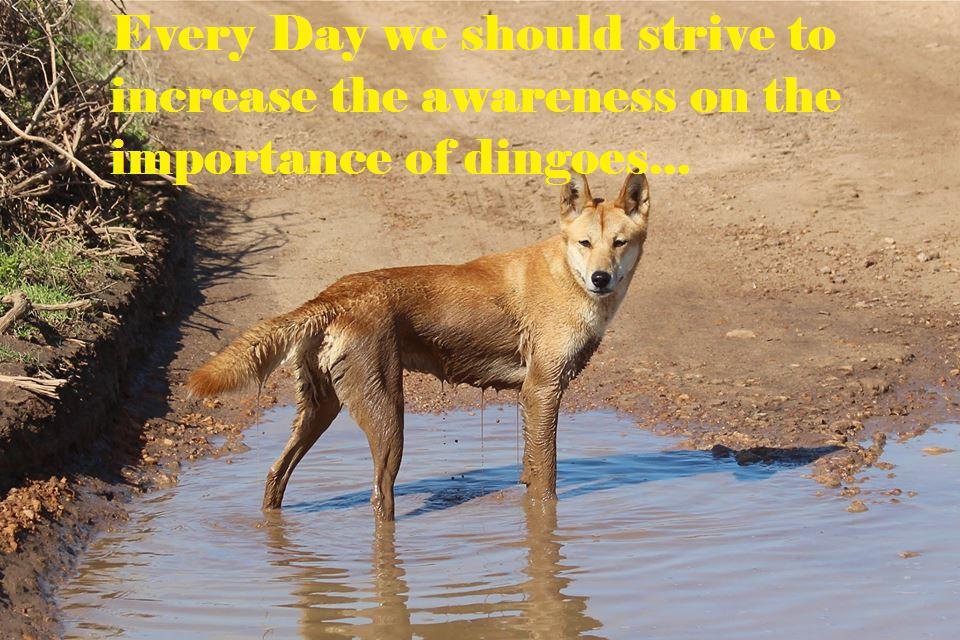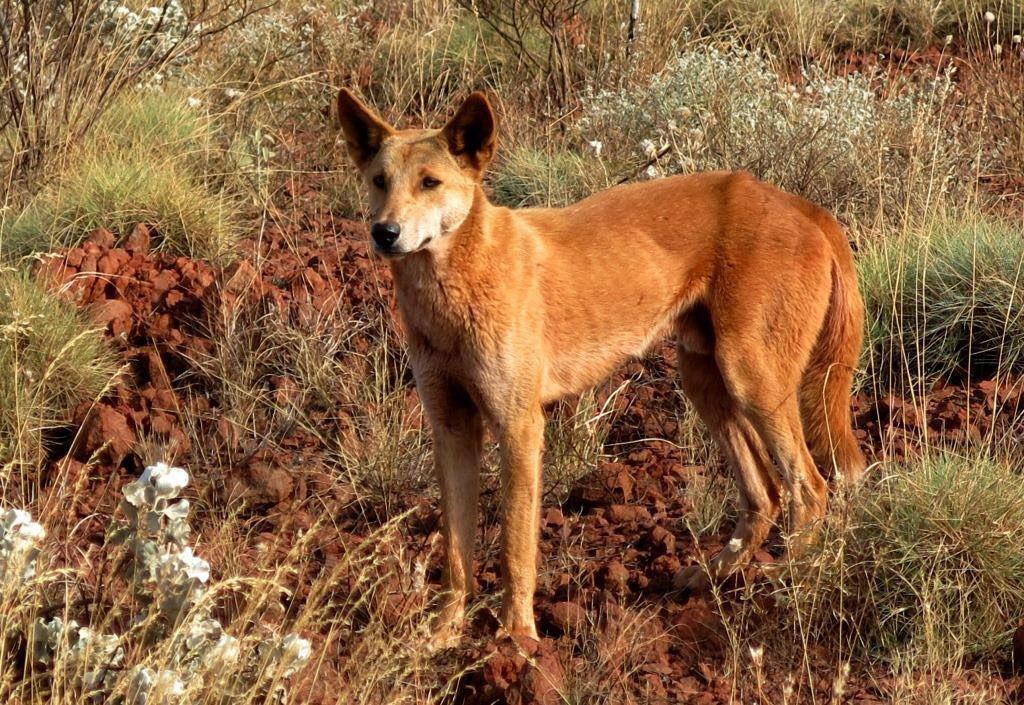The first image is the image on the left, the second image is the image on the right. Analyze the images presented: Is the assertion "A dingo is surrounded by a grass and flowered ground cover" valid? Answer yes or no. Yes. The first image is the image on the left, the second image is the image on the right. Assess this claim about the two images: "Each image shows a single dingo standing on all fours, and the dingo on the right has its body turned leftward.". Correct or not? Answer yes or no. Yes. 